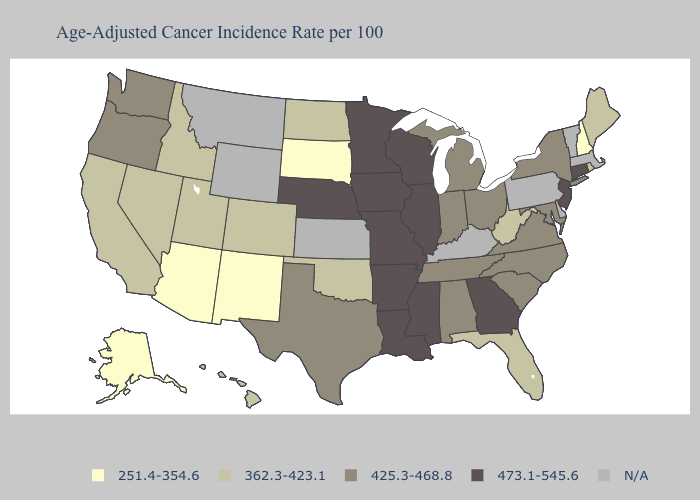Among the states that border Idaho , does Utah have the lowest value?
Concise answer only. Yes. How many symbols are there in the legend?
Give a very brief answer. 5. Does Oregon have the highest value in the West?
Answer briefly. Yes. Name the states that have a value in the range 362.3-423.1?
Give a very brief answer. California, Colorado, Florida, Hawaii, Idaho, Maine, Nevada, North Dakota, Oklahoma, Rhode Island, Utah, West Virginia. Among the states that border Arizona , which have the highest value?
Answer briefly. California, Colorado, Nevada, Utah. What is the value of New Mexico?
Keep it brief. 251.4-354.6. Among the states that border Massachusetts , does Connecticut have the lowest value?
Concise answer only. No. Which states have the highest value in the USA?
Give a very brief answer. Arkansas, Connecticut, Georgia, Illinois, Iowa, Louisiana, Minnesota, Mississippi, Missouri, Nebraska, New Jersey, Wisconsin. What is the lowest value in states that border Alabama?
Keep it brief. 362.3-423.1. Which states have the lowest value in the USA?
Quick response, please. Alaska, Arizona, New Hampshire, New Mexico, South Dakota. Name the states that have a value in the range N/A?
Give a very brief answer. Delaware, Kansas, Kentucky, Massachusetts, Montana, Pennsylvania, Vermont, Wyoming. What is the value of Idaho?
Answer briefly. 362.3-423.1. 